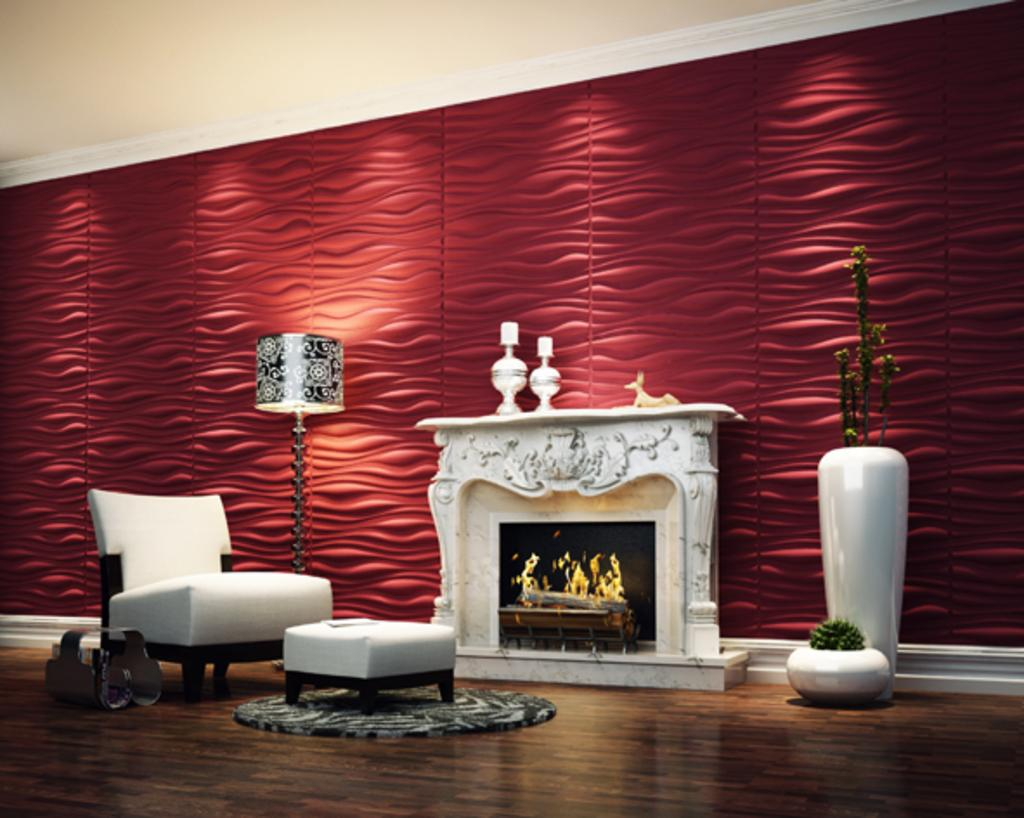What type of flooring is visible in the image? There is a wooden floor in the image. What type of furniture is present in the image? There is a table and a chair in the image. What is the primary source of light in the image? There is a lantern lamp in the image. What type of plants are visible in the image? There are plants in the image. What is the design on the wall in the image? The wall has a red design. What is the purpose of the fireplace in the image? The fireplace is likely for heating or decoration. What objects are present on the fireplace? Objects are present on the fireplace. How many degrees does the needle on the fireplace indicate in the image? There is no needle present in the image, as it is a fireplace and not a thermometer. What type of rainstorm is depicted in the image? There is no rainstorm present in the image; it is an indoor scene with a fireplace, table, chair, and other objects. 